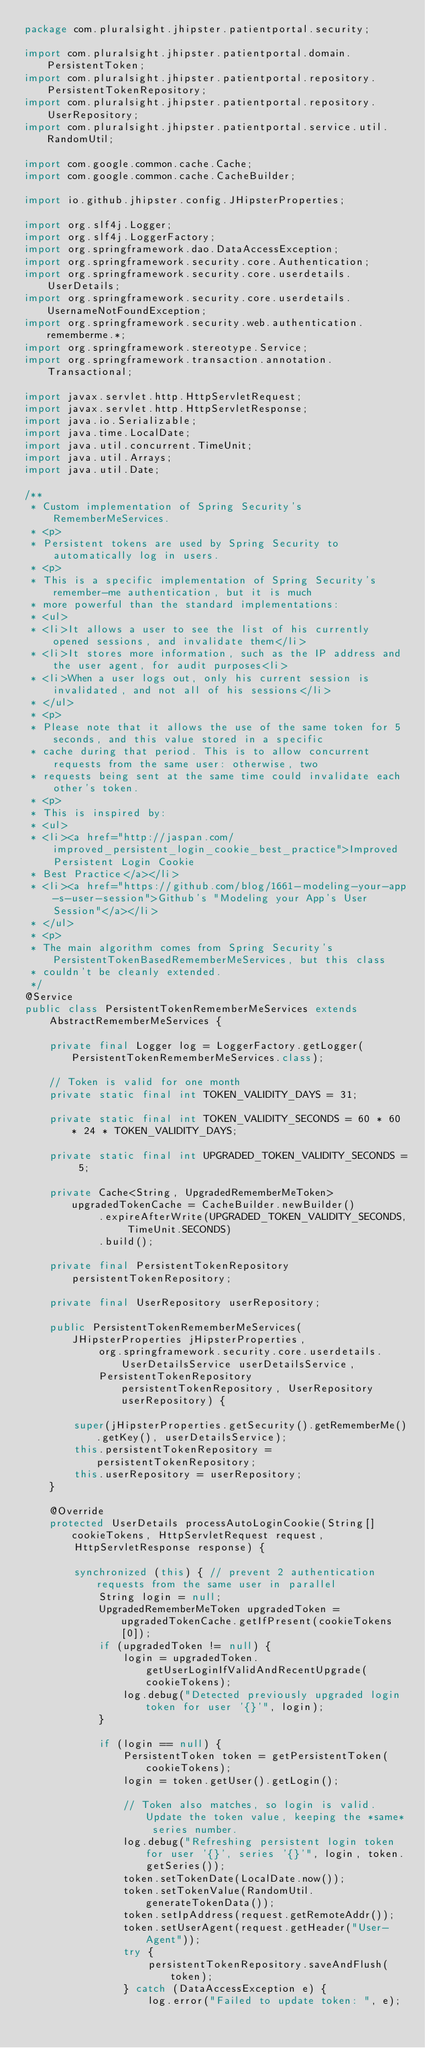<code> <loc_0><loc_0><loc_500><loc_500><_Java_>package com.pluralsight.jhipster.patientportal.security;

import com.pluralsight.jhipster.patientportal.domain.PersistentToken;
import com.pluralsight.jhipster.patientportal.repository.PersistentTokenRepository;
import com.pluralsight.jhipster.patientportal.repository.UserRepository;
import com.pluralsight.jhipster.patientportal.service.util.RandomUtil;

import com.google.common.cache.Cache;
import com.google.common.cache.CacheBuilder;

import io.github.jhipster.config.JHipsterProperties;

import org.slf4j.Logger;
import org.slf4j.LoggerFactory;
import org.springframework.dao.DataAccessException;
import org.springframework.security.core.Authentication;
import org.springframework.security.core.userdetails.UserDetails;
import org.springframework.security.core.userdetails.UsernameNotFoundException;
import org.springframework.security.web.authentication.rememberme.*;
import org.springframework.stereotype.Service;
import org.springframework.transaction.annotation.Transactional;

import javax.servlet.http.HttpServletRequest;
import javax.servlet.http.HttpServletResponse;
import java.io.Serializable;
import java.time.LocalDate;
import java.util.concurrent.TimeUnit;
import java.util.Arrays;
import java.util.Date;

/**
 * Custom implementation of Spring Security's RememberMeServices.
 * <p>
 * Persistent tokens are used by Spring Security to automatically log in users.
 * <p>
 * This is a specific implementation of Spring Security's remember-me authentication, but it is much
 * more powerful than the standard implementations:
 * <ul>
 * <li>It allows a user to see the list of his currently opened sessions, and invalidate them</li>
 * <li>It stores more information, such as the IP address and the user agent, for audit purposes<li>
 * <li>When a user logs out, only his current session is invalidated, and not all of his sessions</li>
 * </ul>
 * <p>
 * Please note that it allows the use of the same token for 5 seconds, and this value stored in a specific
 * cache during that period. This is to allow concurrent requests from the same user: otherwise, two
 * requests being sent at the same time could invalidate each other's token.
 * <p>
 * This is inspired by:
 * <ul>
 * <li><a href="http://jaspan.com/improved_persistent_login_cookie_best_practice">Improved Persistent Login Cookie
 * Best Practice</a></li>
 * <li><a href="https://github.com/blog/1661-modeling-your-app-s-user-session">Github's "Modeling your App's User Session"</a></li>
 * </ul>
 * <p>
 * The main algorithm comes from Spring Security's PersistentTokenBasedRememberMeServices, but this class
 * couldn't be cleanly extended.
 */
@Service
public class PersistentTokenRememberMeServices extends
    AbstractRememberMeServices {

    private final Logger log = LoggerFactory.getLogger(PersistentTokenRememberMeServices.class);

    // Token is valid for one month
    private static final int TOKEN_VALIDITY_DAYS = 31;

    private static final int TOKEN_VALIDITY_SECONDS = 60 * 60 * 24 * TOKEN_VALIDITY_DAYS;

    private static final int UPGRADED_TOKEN_VALIDITY_SECONDS = 5;

    private Cache<String, UpgradedRememberMeToken> upgradedTokenCache = CacheBuilder.newBuilder()
            .expireAfterWrite(UPGRADED_TOKEN_VALIDITY_SECONDS, TimeUnit.SECONDS)
            .build();

    private final PersistentTokenRepository persistentTokenRepository;

    private final UserRepository userRepository;

    public PersistentTokenRememberMeServices(JHipsterProperties jHipsterProperties,
            org.springframework.security.core.userdetails.UserDetailsService userDetailsService,
            PersistentTokenRepository persistentTokenRepository, UserRepository userRepository) {

        super(jHipsterProperties.getSecurity().getRememberMe().getKey(), userDetailsService);
        this.persistentTokenRepository = persistentTokenRepository;
        this.userRepository = userRepository;
    }

    @Override
    protected UserDetails processAutoLoginCookie(String[] cookieTokens, HttpServletRequest request,
        HttpServletResponse response) {

        synchronized (this) { // prevent 2 authentication requests from the same user in parallel
            String login = null;
            UpgradedRememberMeToken upgradedToken = upgradedTokenCache.getIfPresent(cookieTokens[0]);
            if (upgradedToken != null) {
                login = upgradedToken.getUserLoginIfValidAndRecentUpgrade(cookieTokens);
                log.debug("Detected previously upgraded login token for user '{}'", login);
            }

            if (login == null) {
                PersistentToken token = getPersistentToken(cookieTokens);
                login = token.getUser().getLogin();

                // Token also matches, so login is valid. Update the token value, keeping the *same* series number.
                log.debug("Refreshing persistent login token for user '{}', series '{}'", login, token.getSeries());
                token.setTokenDate(LocalDate.now());
                token.setTokenValue(RandomUtil.generateTokenData());
                token.setIpAddress(request.getRemoteAddr());
                token.setUserAgent(request.getHeader("User-Agent"));
                try {
                    persistentTokenRepository.saveAndFlush(token);
                } catch (DataAccessException e) {
                    log.error("Failed to update token: ", e);</code> 